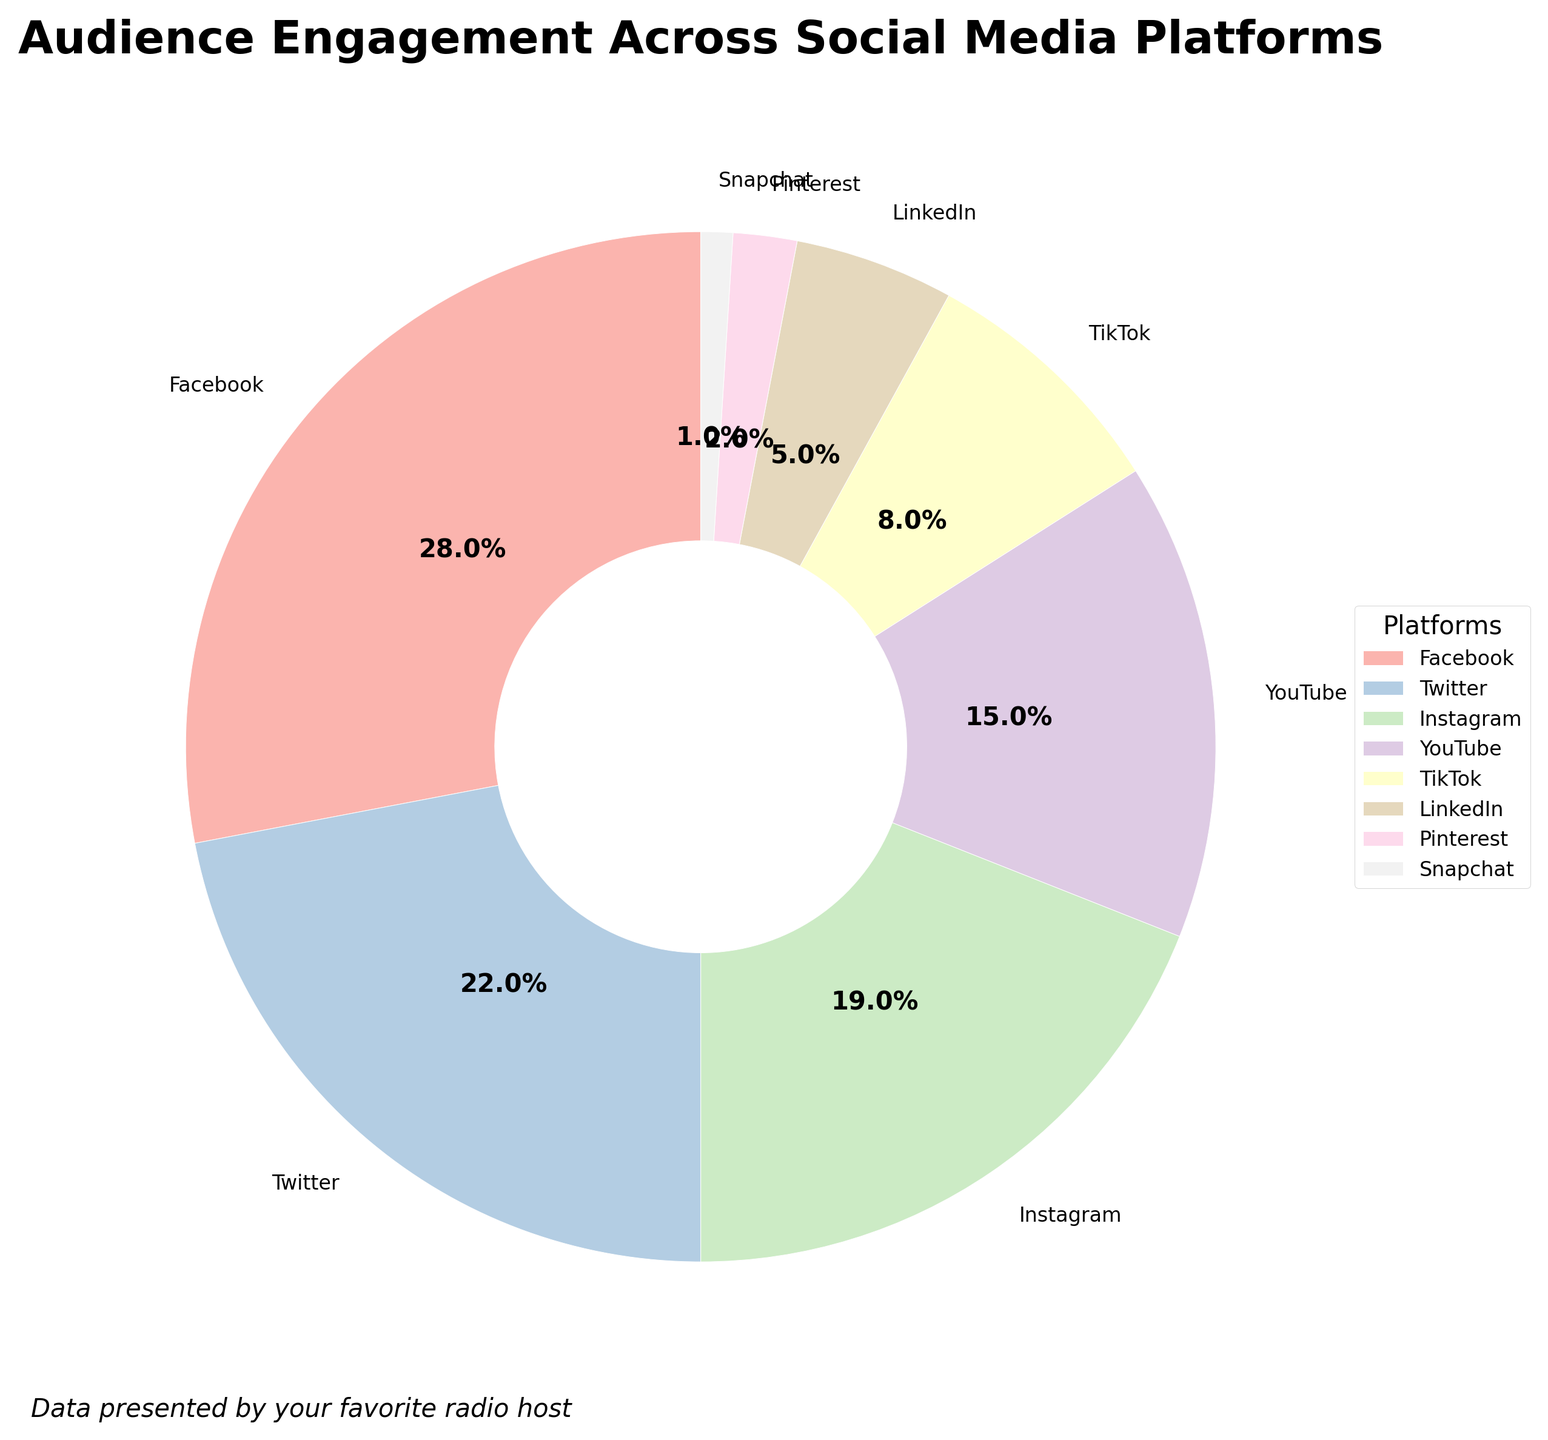What's the largest slice in the pie chart? To find the largest slice, look at the percentage values and identify the one with the highest number. Facebook has the largest percentage at 28%.
Answer: Facebook Which platform has a higher audience engagement, Instagram or YouTube? Compare the percentages for Instagram and YouTube. Instagram has 19% while YouTube has 15%. Therefore, Instagram has a higher audience engagement.
Answer: Instagram What is the combined audience engagement for Twitter and TikTok? Add the percentages of Twitter and TikTok: 22% + 8% = 30%.
Answer: 30% Is the engagement on LinkedIn greater than that on Pinterest? Compare the percentages for LinkedIn and Pinterest. LinkedIn has 5% and Pinterest has 2%, so LinkedIn's engagement is greater.
Answer: Yes How much lower is Snapchat’s engagement compared to YouTube’s? Subtract Snapchat’s percentage from YouTube’s: 15% - 1% = 14%.
Answer: 14% What is the average audience engagement for Facebook, Twitter, and Instagram? Add the percentages of Facebook, Twitter, and Instagram and then divide by the number of platforms: (28% + 22% + 19%) / 3 = 23%.
Answer: 23% Which two platforms together account for more than half of the total audience engagement? Combine different platforms' percentages to see which pairs exceed 50%. Facebook (28%) and Twitter (22%) together total 50%, but adding Instagram (19%) and Facebook (28%) equals 47%. Therefore, Facebook and Instagram together exceed 50%.
Answer: Facebook and Instagram What color represents the slice for Pinterest? Look at the pie chart and find the slice labeled “Pinterest.” The color associated with Pinterest is typically identified as one of the standardized colors.
Answer: Pastel (lightest color) How does the width of the wedges affect the visibility of the percentages? The width of the wedges is thinner than full pie slices (0.6), which focuses on the wedge proportions and leaves more room for individual percentage labels to be clearly visible.
Answer: It improves clarity 